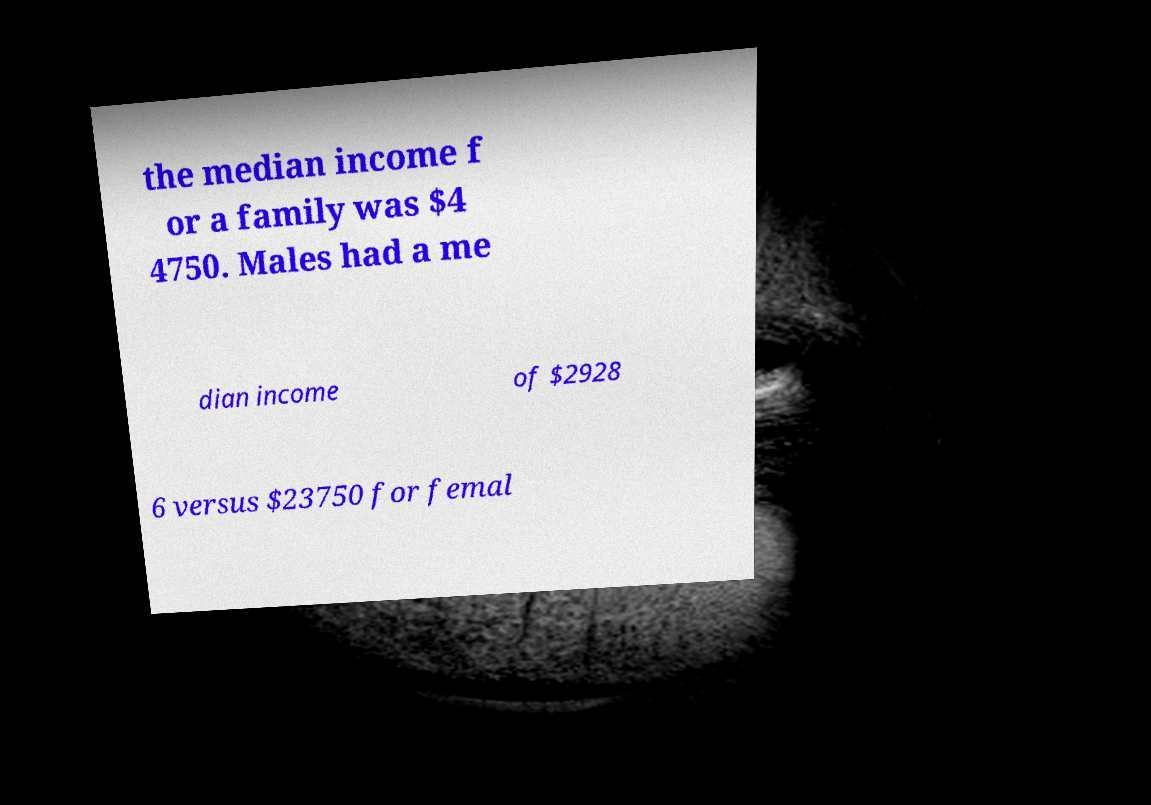I need the written content from this picture converted into text. Can you do that? the median income f or a family was $4 4750. Males had a me dian income of $2928 6 versus $23750 for femal 